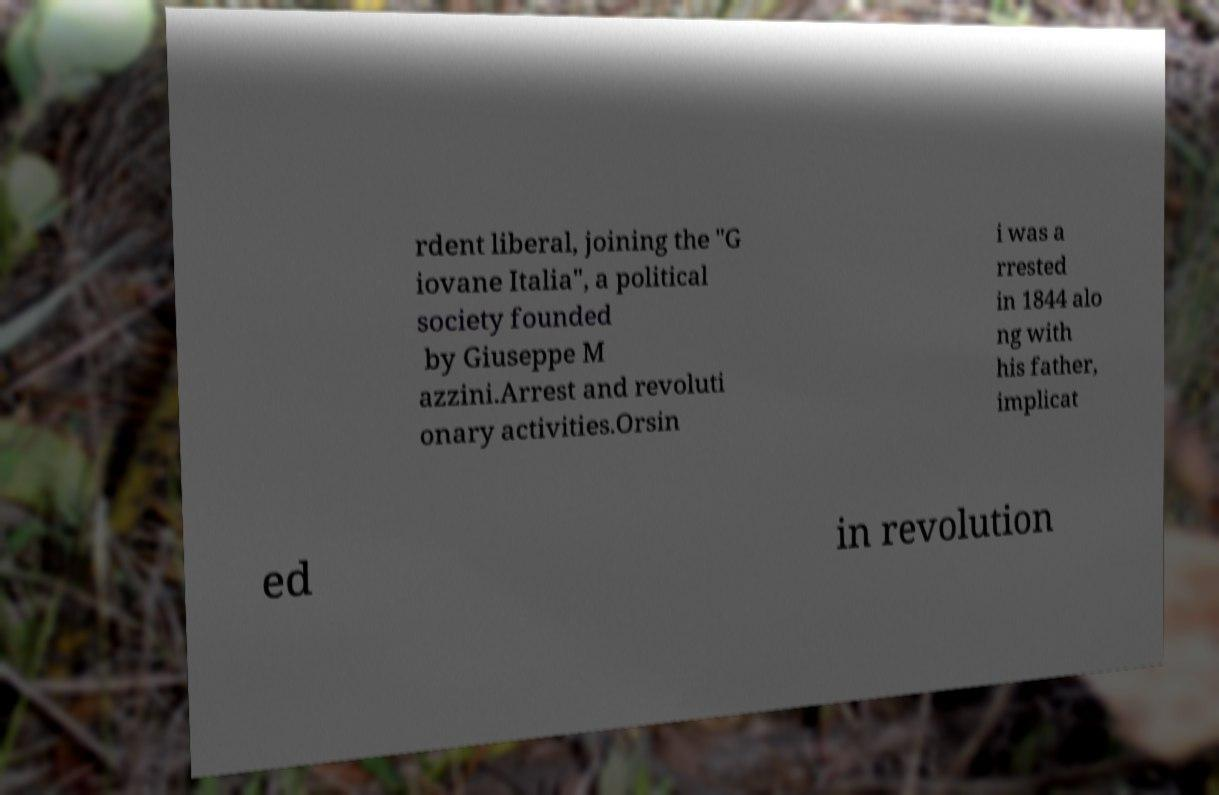Please identify and transcribe the text found in this image. rdent liberal, joining the "G iovane Italia", a political society founded by Giuseppe M azzini.Arrest and revoluti onary activities.Orsin i was a rrested in 1844 alo ng with his father, implicat ed in revolution 